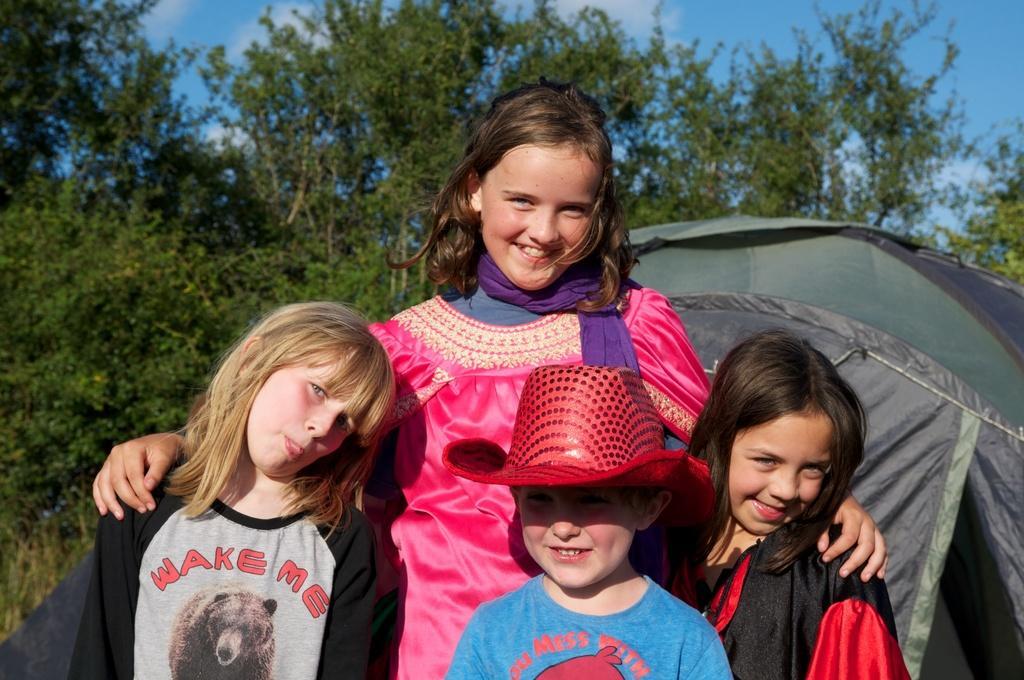Can you describe this image briefly? This image consists of four persons. In the middle, the boy is wearing a red hat. In the background, the girl is wearing a pink dress. On the right, there is a tent. In the background, there are trees. At the top, there is sky. 